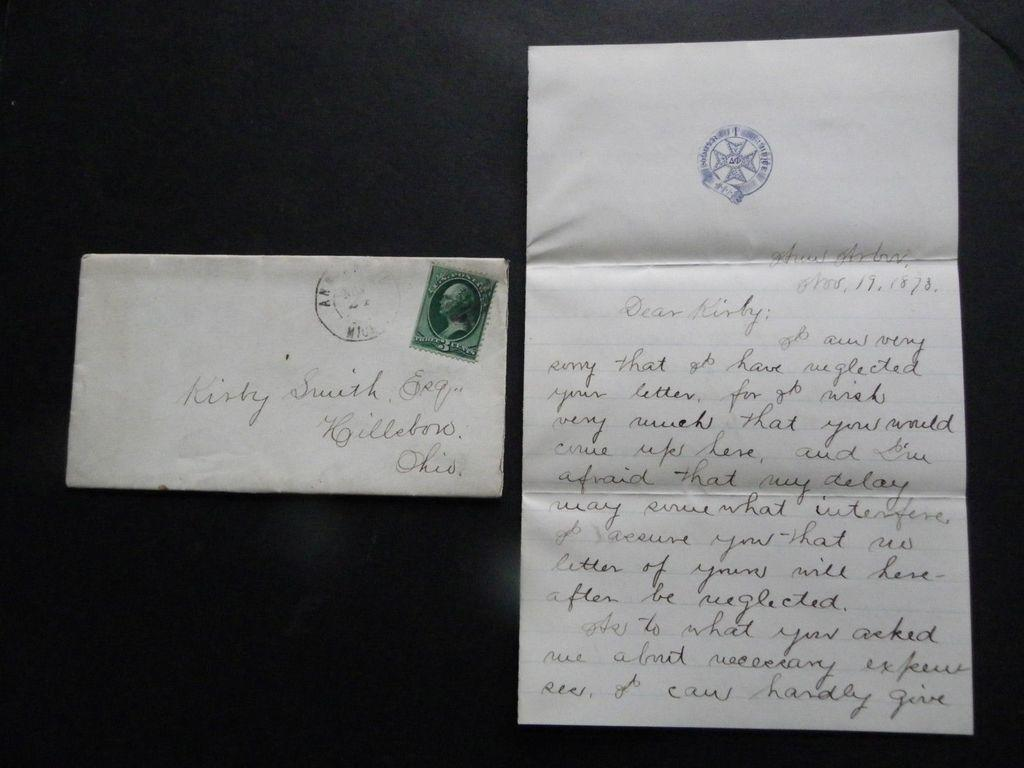<image>
Summarize the visual content of the image. An envelope addressed to Kirby Smith and the associated letter. 